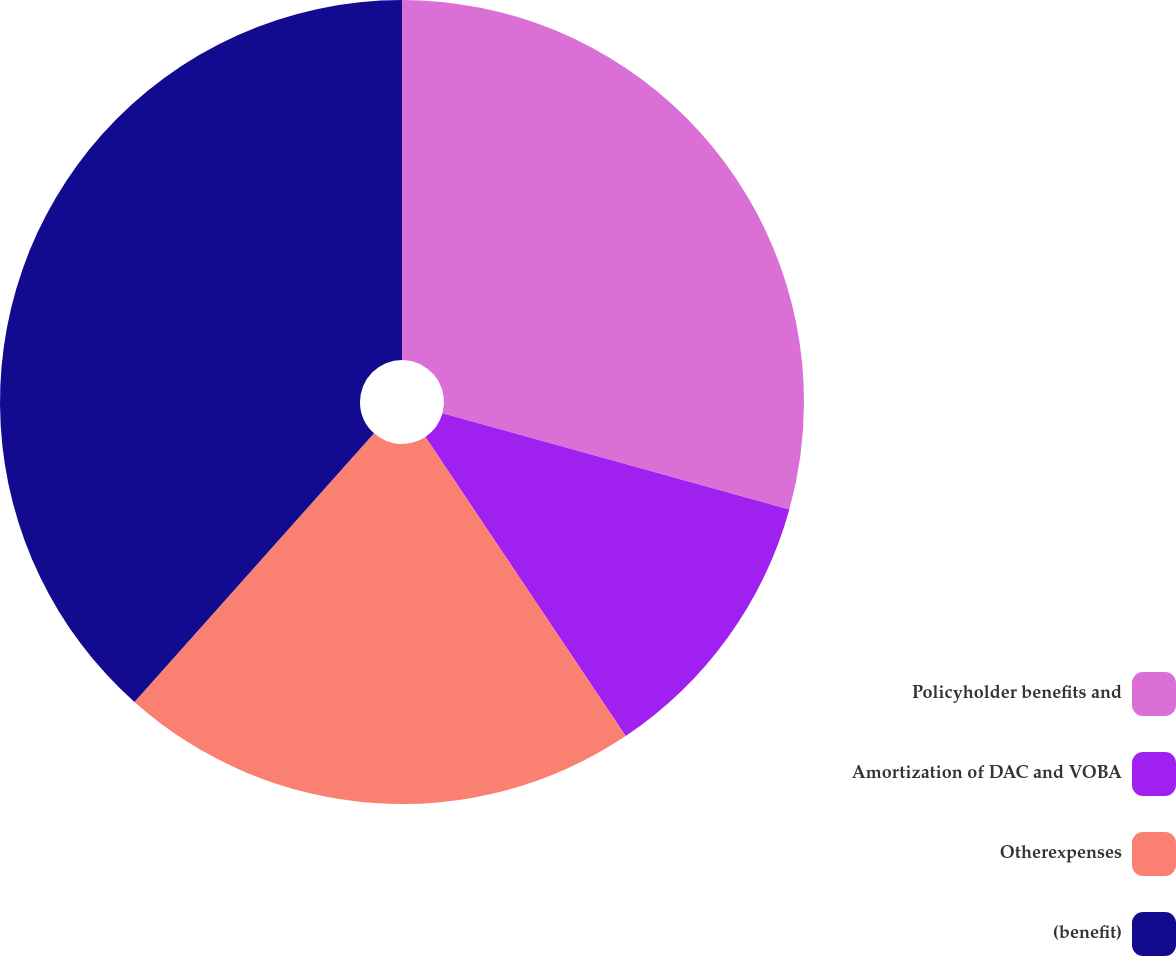<chart> <loc_0><loc_0><loc_500><loc_500><pie_chart><fcel>Policyholder benefits and<fcel>Amortization of DAC and VOBA<fcel>Otherexpenses<fcel>(benefit)<nl><fcel>29.31%<fcel>11.3%<fcel>20.98%<fcel>38.41%<nl></chart> 